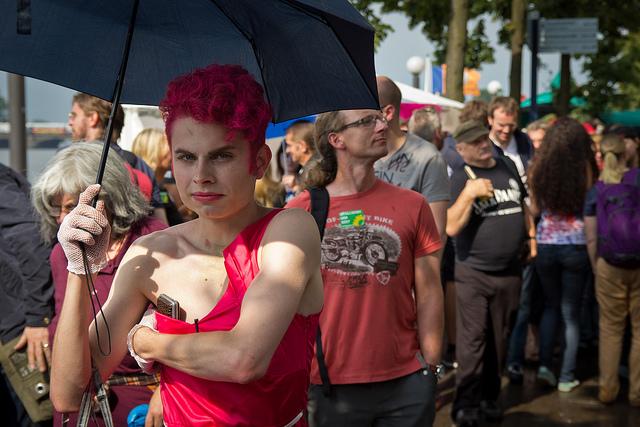Is the red head a man or a woman?
Concise answer only. Man. What color is the umbrella on the left?
Concise answer only. Black. Are any of the men in the photo wearing suits?
Short answer required. No. What is the person in the pink shirt holding?
Write a very short answer. Umbrella. What is in the person's shirt?
Concise answer only. Phone. 